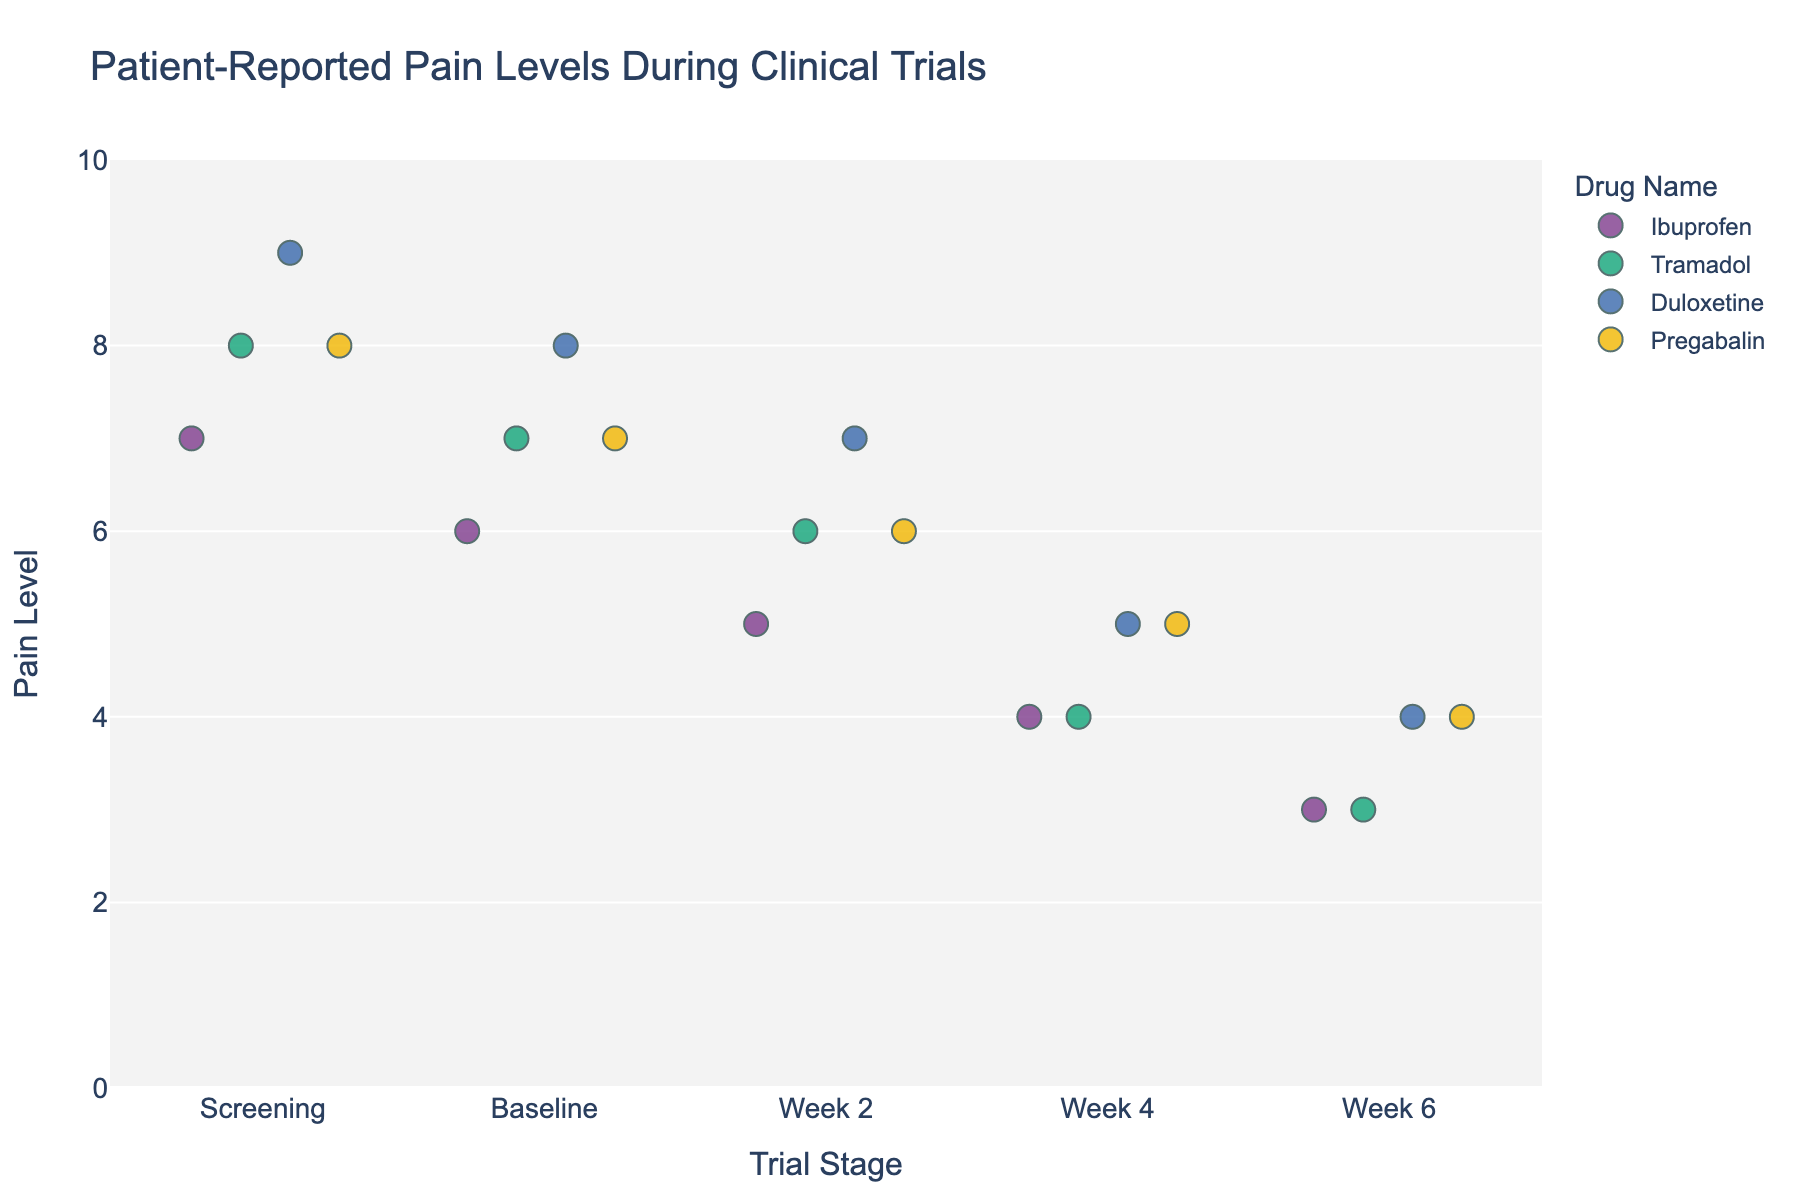What is the title of the plot? The title of the plot is prominently displayed at the top of the figure. It is generally used to summarize what the plot is about.
Answer: Patient-Reported Pain Levels During Clinical Trials How many drugs are being compared in the plot? Count the number of unique colors in the plot. Each color represents a different drug.
Answer: 4 Which drug shows the lowest pain level at Week 6? Locate the data points for Week 6. Identify which color or drug is associated with the lowest value at that stage.
Answer: Ibuprofen and Tramadol At the Screening stage, which drug had the highest reported pain level? Look at the data points for the Screening stage and identify which one is the highest. Note the corresponding drug color/name.
Answer: Duloxetine By how much did the pain level decrease for Tramadol users from Screening to Week 6? Find the data points for Tramadol at Screening and Week 6. Subtract the Week 6 value from the Screening value.
Answer: 5 Which trial stage has the most variation in reported pain levels across all drugs? Compare the spread of data points (along the y-axis) for each trial stage. The stage with the most spread has the most variation.
Answer: Screening Which drug shows the least improvement in pain levels from Screening to Week 6? Calculate the difference in pain levels from Screening to Week 6 for each drug. The smallest difference indicates the least improvement.
Answer: Duloxetine For which stages do Ibuprofen and Pregabalin have the same reported pain levels? Compare the pain levels of Ibuprofen and Pregabalin across all the trial stages. Identify stages where the pain levels are equal.
Answer: Baseline (7), Week 2 (6), Week 4 (5), Week 6 (4) Which drug had consistently decreasing pain levels throughout all stages? Check the trend for each drug across all stages. A consistently decreasing line indicates the pain level decreased at each subsequent stage.
Answer: All drugs (Ibuprofen, Tramadol, Duloxetine, Pregabalin) 